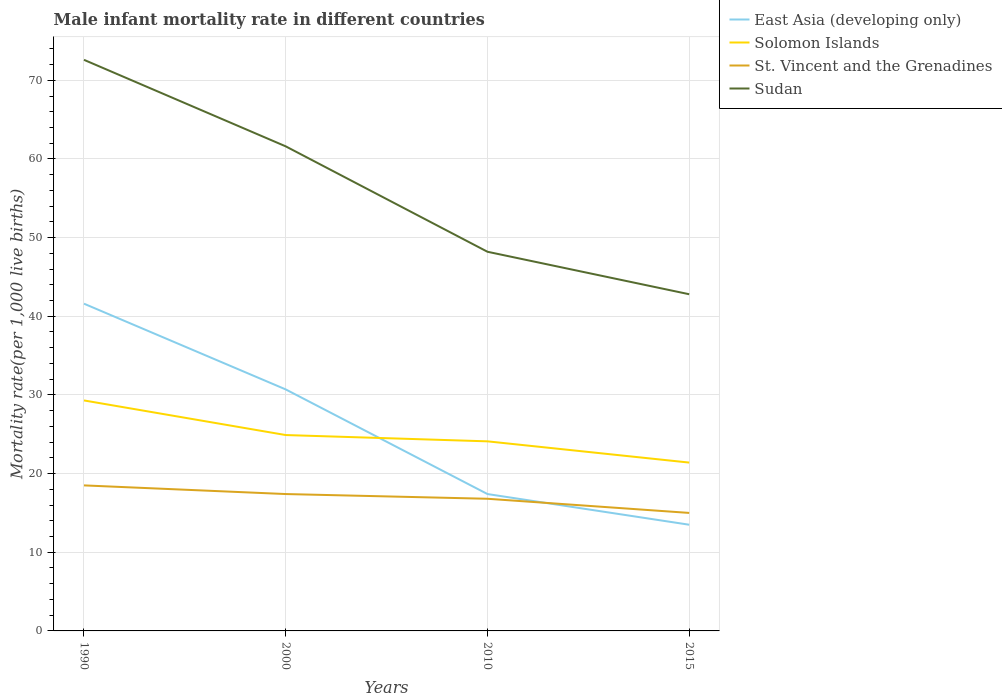Does the line corresponding to East Asia (developing only) intersect with the line corresponding to Sudan?
Offer a very short reply. No. Across all years, what is the maximum male infant mortality rate in Solomon Islands?
Keep it short and to the point. 21.4. In which year was the male infant mortality rate in Sudan maximum?
Keep it short and to the point. 2015. What is the total male infant mortality rate in Sudan in the graph?
Provide a short and direct response. 5.4. What is the difference between the highest and the lowest male infant mortality rate in Sudan?
Keep it short and to the point. 2. Is the male infant mortality rate in Sudan strictly greater than the male infant mortality rate in East Asia (developing only) over the years?
Your answer should be very brief. No. What is the difference between two consecutive major ticks on the Y-axis?
Keep it short and to the point. 10. Does the graph contain any zero values?
Keep it short and to the point. No. What is the title of the graph?
Your answer should be compact. Male infant mortality rate in different countries. Does "Venezuela" appear as one of the legend labels in the graph?
Your answer should be compact. No. What is the label or title of the Y-axis?
Your answer should be compact. Mortality rate(per 1,0 live births). What is the Mortality rate(per 1,000 live births) in East Asia (developing only) in 1990?
Offer a terse response. 41.6. What is the Mortality rate(per 1,000 live births) in Solomon Islands in 1990?
Provide a short and direct response. 29.3. What is the Mortality rate(per 1,000 live births) of Sudan in 1990?
Provide a short and direct response. 72.6. What is the Mortality rate(per 1,000 live births) of East Asia (developing only) in 2000?
Your response must be concise. 30.7. What is the Mortality rate(per 1,000 live births) of Solomon Islands in 2000?
Ensure brevity in your answer.  24.9. What is the Mortality rate(per 1,000 live births) in Sudan in 2000?
Provide a short and direct response. 61.6. What is the Mortality rate(per 1,000 live births) in Solomon Islands in 2010?
Make the answer very short. 24.1. What is the Mortality rate(per 1,000 live births) in Sudan in 2010?
Offer a terse response. 48.2. What is the Mortality rate(per 1,000 live births) in Solomon Islands in 2015?
Ensure brevity in your answer.  21.4. What is the Mortality rate(per 1,000 live births) in Sudan in 2015?
Give a very brief answer. 42.8. Across all years, what is the maximum Mortality rate(per 1,000 live births) of East Asia (developing only)?
Offer a terse response. 41.6. Across all years, what is the maximum Mortality rate(per 1,000 live births) in Solomon Islands?
Keep it short and to the point. 29.3. Across all years, what is the maximum Mortality rate(per 1,000 live births) in Sudan?
Ensure brevity in your answer.  72.6. Across all years, what is the minimum Mortality rate(per 1,000 live births) in East Asia (developing only)?
Offer a terse response. 13.5. Across all years, what is the minimum Mortality rate(per 1,000 live births) of Solomon Islands?
Provide a succinct answer. 21.4. Across all years, what is the minimum Mortality rate(per 1,000 live births) in Sudan?
Your response must be concise. 42.8. What is the total Mortality rate(per 1,000 live births) in East Asia (developing only) in the graph?
Your answer should be very brief. 103.2. What is the total Mortality rate(per 1,000 live births) of Solomon Islands in the graph?
Keep it short and to the point. 99.7. What is the total Mortality rate(per 1,000 live births) in St. Vincent and the Grenadines in the graph?
Keep it short and to the point. 67.7. What is the total Mortality rate(per 1,000 live births) in Sudan in the graph?
Provide a short and direct response. 225.2. What is the difference between the Mortality rate(per 1,000 live births) in Solomon Islands in 1990 and that in 2000?
Make the answer very short. 4.4. What is the difference between the Mortality rate(per 1,000 live births) of East Asia (developing only) in 1990 and that in 2010?
Ensure brevity in your answer.  24.2. What is the difference between the Mortality rate(per 1,000 live births) in Solomon Islands in 1990 and that in 2010?
Your response must be concise. 5.2. What is the difference between the Mortality rate(per 1,000 live births) in St. Vincent and the Grenadines in 1990 and that in 2010?
Ensure brevity in your answer.  1.7. What is the difference between the Mortality rate(per 1,000 live births) in Sudan in 1990 and that in 2010?
Offer a terse response. 24.4. What is the difference between the Mortality rate(per 1,000 live births) of East Asia (developing only) in 1990 and that in 2015?
Keep it short and to the point. 28.1. What is the difference between the Mortality rate(per 1,000 live births) in Solomon Islands in 1990 and that in 2015?
Provide a succinct answer. 7.9. What is the difference between the Mortality rate(per 1,000 live births) of St. Vincent and the Grenadines in 1990 and that in 2015?
Give a very brief answer. 3.5. What is the difference between the Mortality rate(per 1,000 live births) of Sudan in 1990 and that in 2015?
Your answer should be compact. 29.8. What is the difference between the Mortality rate(per 1,000 live births) in East Asia (developing only) in 2000 and that in 2010?
Give a very brief answer. 13.3. What is the difference between the Mortality rate(per 1,000 live births) in East Asia (developing only) in 2000 and that in 2015?
Provide a succinct answer. 17.2. What is the difference between the Mortality rate(per 1,000 live births) of St. Vincent and the Grenadines in 2000 and that in 2015?
Keep it short and to the point. 2.4. What is the difference between the Mortality rate(per 1,000 live births) in East Asia (developing only) in 2010 and that in 2015?
Offer a terse response. 3.9. What is the difference between the Mortality rate(per 1,000 live births) in Solomon Islands in 2010 and that in 2015?
Provide a succinct answer. 2.7. What is the difference between the Mortality rate(per 1,000 live births) in Sudan in 2010 and that in 2015?
Make the answer very short. 5.4. What is the difference between the Mortality rate(per 1,000 live births) in East Asia (developing only) in 1990 and the Mortality rate(per 1,000 live births) in St. Vincent and the Grenadines in 2000?
Your answer should be compact. 24.2. What is the difference between the Mortality rate(per 1,000 live births) of East Asia (developing only) in 1990 and the Mortality rate(per 1,000 live births) of Sudan in 2000?
Ensure brevity in your answer.  -20. What is the difference between the Mortality rate(per 1,000 live births) in Solomon Islands in 1990 and the Mortality rate(per 1,000 live births) in Sudan in 2000?
Make the answer very short. -32.3. What is the difference between the Mortality rate(per 1,000 live births) in St. Vincent and the Grenadines in 1990 and the Mortality rate(per 1,000 live births) in Sudan in 2000?
Your answer should be very brief. -43.1. What is the difference between the Mortality rate(per 1,000 live births) in East Asia (developing only) in 1990 and the Mortality rate(per 1,000 live births) in St. Vincent and the Grenadines in 2010?
Your answer should be compact. 24.8. What is the difference between the Mortality rate(per 1,000 live births) of East Asia (developing only) in 1990 and the Mortality rate(per 1,000 live births) of Sudan in 2010?
Give a very brief answer. -6.6. What is the difference between the Mortality rate(per 1,000 live births) in Solomon Islands in 1990 and the Mortality rate(per 1,000 live births) in Sudan in 2010?
Offer a very short reply. -18.9. What is the difference between the Mortality rate(per 1,000 live births) of St. Vincent and the Grenadines in 1990 and the Mortality rate(per 1,000 live births) of Sudan in 2010?
Give a very brief answer. -29.7. What is the difference between the Mortality rate(per 1,000 live births) in East Asia (developing only) in 1990 and the Mortality rate(per 1,000 live births) in Solomon Islands in 2015?
Keep it short and to the point. 20.2. What is the difference between the Mortality rate(per 1,000 live births) in East Asia (developing only) in 1990 and the Mortality rate(per 1,000 live births) in St. Vincent and the Grenadines in 2015?
Your answer should be compact. 26.6. What is the difference between the Mortality rate(per 1,000 live births) in St. Vincent and the Grenadines in 1990 and the Mortality rate(per 1,000 live births) in Sudan in 2015?
Your response must be concise. -24.3. What is the difference between the Mortality rate(per 1,000 live births) of East Asia (developing only) in 2000 and the Mortality rate(per 1,000 live births) of Sudan in 2010?
Ensure brevity in your answer.  -17.5. What is the difference between the Mortality rate(per 1,000 live births) of Solomon Islands in 2000 and the Mortality rate(per 1,000 live births) of Sudan in 2010?
Your answer should be compact. -23.3. What is the difference between the Mortality rate(per 1,000 live births) in St. Vincent and the Grenadines in 2000 and the Mortality rate(per 1,000 live births) in Sudan in 2010?
Provide a short and direct response. -30.8. What is the difference between the Mortality rate(per 1,000 live births) in East Asia (developing only) in 2000 and the Mortality rate(per 1,000 live births) in St. Vincent and the Grenadines in 2015?
Your answer should be very brief. 15.7. What is the difference between the Mortality rate(per 1,000 live births) in East Asia (developing only) in 2000 and the Mortality rate(per 1,000 live births) in Sudan in 2015?
Provide a succinct answer. -12.1. What is the difference between the Mortality rate(per 1,000 live births) in Solomon Islands in 2000 and the Mortality rate(per 1,000 live births) in St. Vincent and the Grenadines in 2015?
Keep it short and to the point. 9.9. What is the difference between the Mortality rate(per 1,000 live births) in Solomon Islands in 2000 and the Mortality rate(per 1,000 live births) in Sudan in 2015?
Make the answer very short. -17.9. What is the difference between the Mortality rate(per 1,000 live births) in St. Vincent and the Grenadines in 2000 and the Mortality rate(per 1,000 live births) in Sudan in 2015?
Provide a short and direct response. -25.4. What is the difference between the Mortality rate(per 1,000 live births) in East Asia (developing only) in 2010 and the Mortality rate(per 1,000 live births) in Solomon Islands in 2015?
Provide a succinct answer. -4. What is the difference between the Mortality rate(per 1,000 live births) in East Asia (developing only) in 2010 and the Mortality rate(per 1,000 live births) in St. Vincent and the Grenadines in 2015?
Keep it short and to the point. 2.4. What is the difference between the Mortality rate(per 1,000 live births) in East Asia (developing only) in 2010 and the Mortality rate(per 1,000 live births) in Sudan in 2015?
Ensure brevity in your answer.  -25.4. What is the difference between the Mortality rate(per 1,000 live births) in Solomon Islands in 2010 and the Mortality rate(per 1,000 live births) in Sudan in 2015?
Ensure brevity in your answer.  -18.7. What is the average Mortality rate(per 1,000 live births) in East Asia (developing only) per year?
Your answer should be very brief. 25.8. What is the average Mortality rate(per 1,000 live births) of Solomon Islands per year?
Offer a very short reply. 24.93. What is the average Mortality rate(per 1,000 live births) in St. Vincent and the Grenadines per year?
Offer a very short reply. 16.93. What is the average Mortality rate(per 1,000 live births) in Sudan per year?
Offer a very short reply. 56.3. In the year 1990, what is the difference between the Mortality rate(per 1,000 live births) of East Asia (developing only) and Mortality rate(per 1,000 live births) of Solomon Islands?
Ensure brevity in your answer.  12.3. In the year 1990, what is the difference between the Mortality rate(per 1,000 live births) of East Asia (developing only) and Mortality rate(per 1,000 live births) of St. Vincent and the Grenadines?
Your answer should be compact. 23.1. In the year 1990, what is the difference between the Mortality rate(per 1,000 live births) in East Asia (developing only) and Mortality rate(per 1,000 live births) in Sudan?
Provide a short and direct response. -31. In the year 1990, what is the difference between the Mortality rate(per 1,000 live births) of Solomon Islands and Mortality rate(per 1,000 live births) of St. Vincent and the Grenadines?
Provide a succinct answer. 10.8. In the year 1990, what is the difference between the Mortality rate(per 1,000 live births) of Solomon Islands and Mortality rate(per 1,000 live births) of Sudan?
Provide a short and direct response. -43.3. In the year 1990, what is the difference between the Mortality rate(per 1,000 live births) in St. Vincent and the Grenadines and Mortality rate(per 1,000 live births) in Sudan?
Offer a very short reply. -54.1. In the year 2000, what is the difference between the Mortality rate(per 1,000 live births) of East Asia (developing only) and Mortality rate(per 1,000 live births) of St. Vincent and the Grenadines?
Your answer should be very brief. 13.3. In the year 2000, what is the difference between the Mortality rate(per 1,000 live births) of East Asia (developing only) and Mortality rate(per 1,000 live births) of Sudan?
Your answer should be compact. -30.9. In the year 2000, what is the difference between the Mortality rate(per 1,000 live births) of Solomon Islands and Mortality rate(per 1,000 live births) of Sudan?
Ensure brevity in your answer.  -36.7. In the year 2000, what is the difference between the Mortality rate(per 1,000 live births) of St. Vincent and the Grenadines and Mortality rate(per 1,000 live births) of Sudan?
Offer a very short reply. -44.2. In the year 2010, what is the difference between the Mortality rate(per 1,000 live births) of East Asia (developing only) and Mortality rate(per 1,000 live births) of St. Vincent and the Grenadines?
Your answer should be very brief. 0.6. In the year 2010, what is the difference between the Mortality rate(per 1,000 live births) in East Asia (developing only) and Mortality rate(per 1,000 live births) in Sudan?
Offer a very short reply. -30.8. In the year 2010, what is the difference between the Mortality rate(per 1,000 live births) in Solomon Islands and Mortality rate(per 1,000 live births) in Sudan?
Make the answer very short. -24.1. In the year 2010, what is the difference between the Mortality rate(per 1,000 live births) of St. Vincent and the Grenadines and Mortality rate(per 1,000 live births) of Sudan?
Keep it short and to the point. -31.4. In the year 2015, what is the difference between the Mortality rate(per 1,000 live births) of East Asia (developing only) and Mortality rate(per 1,000 live births) of Solomon Islands?
Provide a succinct answer. -7.9. In the year 2015, what is the difference between the Mortality rate(per 1,000 live births) of East Asia (developing only) and Mortality rate(per 1,000 live births) of Sudan?
Your answer should be very brief. -29.3. In the year 2015, what is the difference between the Mortality rate(per 1,000 live births) in Solomon Islands and Mortality rate(per 1,000 live births) in Sudan?
Provide a succinct answer. -21.4. In the year 2015, what is the difference between the Mortality rate(per 1,000 live births) of St. Vincent and the Grenadines and Mortality rate(per 1,000 live births) of Sudan?
Make the answer very short. -27.8. What is the ratio of the Mortality rate(per 1,000 live births) in East Asia (developing only) in 1990 to that in 2000?
Provide a short and direct response. 1.35. What is the ratio of the Mortality rate(per 1,000 live births) of Solomon Islands in 1990 to that in 2000?
Give a very brief answer. 1.18. What is the ratio of the Mortality rate(per 1,000 live births) in St. Vincent and the Grenadines in 1990 to that in 2000?
Make the answer very short. 1.06. What is the ratio of the Mortality rate(per 1,000 live births) in Sudan in 1990 to that in 2000?
Offer a terse response. 1.18. What is the ratio of the Mortality rate(per 1,000 live births) in East Asia (developing only) in 1990 to that in 2010?
Keep it short and to the point. 2.39. What is the ratio of the Mortality rate(per 1,000 live births) in Solomon Islands in 1990 to that in 2010?
Offer a very short reply. 1.22. What is the ratio of the Mortality rate(per 1,000 live births) of St. Vincent and the Grenadines in 1990 to that in 2010?
Provide a succinct answer. 1.1. What is the ratio of the Mortality rate(per 1,000 live births) in Sudan in 1990 to that in 2010?
Your response must be concise. 1.51. What is the ratio of the Mortality rate(per 1,000 live births) of East Asia (developing only) in 1990 to that in 2015?
Ensure brevity in your answer.  3.08. What is the ratio of the Mortality rate(per 1,000 live births) of Solomon Islands in 1990 to that in 2015?
Offer a very short reply. 1.37. What is the ratio of the Mortality rate(per 1,000 live births) in St. Vincent and the Grenadines in 1990 to that in 2015?
Offer a terse response. 1.23. What is the ratio of the Mortality rate(per 1,000 live births) in Sudan in 1990 to that in 2015?
Keep it short and to the point. 1.7. What is the ratio of the Mortality rate(per 1,000 live births) of East Asia (developing only) in 2000 to that in 2010?
Keep it short and to the point. 1.76. What is the ratio of the Mortality rate(per 1,000 live births) in Solomon Islands in 2000 to that in 2010?
Keep it short and to the point. 1.03. What is the ratio of the Mortality rate(per 1,000 live births) in St. Vincent and the Grenadines in 2000 to that in 2010?
Provide a succinct answer. 1.04. What is the ratio of the Mortality rate(per 1,000 live births) of Sudan in 2000 to that in 2010?
Offer a very short reply. 1.28. What is the ratio of the Mortality rate(per 1,000 live births) of East Asia (developing only) in 2000 to that in 2015?
Your response must be concise. 2.27. What is the ratio of the Mortality rate(per 1,000 live births) of Solomon Islands in 2000 to that in 2015?
Ensure brevity in your answer.  1.16. What is the ratio of the Mortality rate(per 1,000 live births) in St. Vincent and the Grenadines in 2000 to that in 2015?
Give a very brief answer. 1.16. What is the ratio of the Mortality rate(per 1,000 live births) of Sudan in 2000 to that in 2015?
Offer a terse response. 1.44. What is the ratio of the Mortality rate(per 1,000 live births) in East Asia (developing only) in 2010 to that in 2015?
Offer a very short reply. 1.29. What is the ratio of the Mortality rate(per 1,000 live births) of Solomon Islands in 2010 to that in 2015?
Make the answer very short. 1.13. What is the ratio of the Mortality rate(per 1,000 live births) in St. Vincent and the Grenadines in 2010 to that in 2015?
Your answer should be compact. 1.12. What is the ratio of the Mortality rate(per 1,000 live births) of Sudan in 2010 to that in 2015?
Your answer should be very brief. 1.13. What is the difference between the highest and the second highest Mortality rate(per 1,000 live births) in St. Vincent and the Grenadines?
Your answer should be very brief. 1.1. What is the difference between the highest and the second highest Mortality rate(per 1,000 live births) in Sudan?
Give a very brief answer. 11. What is the difference between the highest and the lowest Mortality rate(per 1,000 live births) of East Asia (developing only)?
Your answer should be very brief. 28.1. What is the difference between the highest and the lowest Mortality rate(per 1,000 live births) in Solomon Islands?
Provide a succinct answer. 7.9. What is the difference between the highest and the lowest Mortality rate(per 1,000 live births) in St. Vincent and the Grenadines?
Keep it short and to the point. 3.5. What is the difference between the highest and the lowest Mortality rate(per 1,000 live births) in Sudan?
Keep it short and to the point. 29.8. 